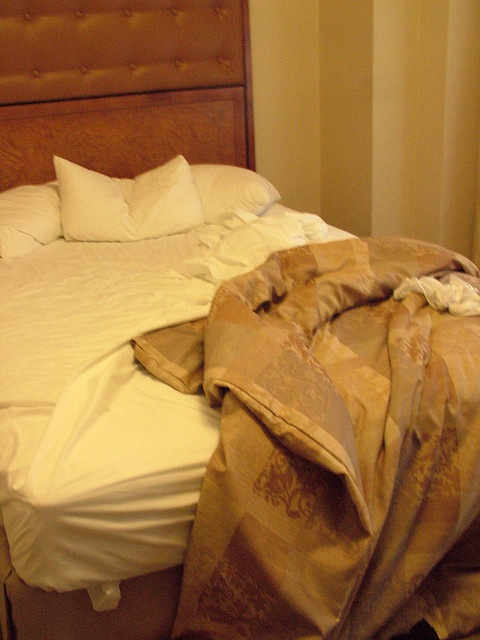Describe the objects in this image and their specific colors. I can see a bed in brown, khaki, tan, and maroon tones in this image. 